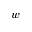Convert formula to latex. <formula><loc_0><loc_0><loc_500><loc_500>w</formula> 